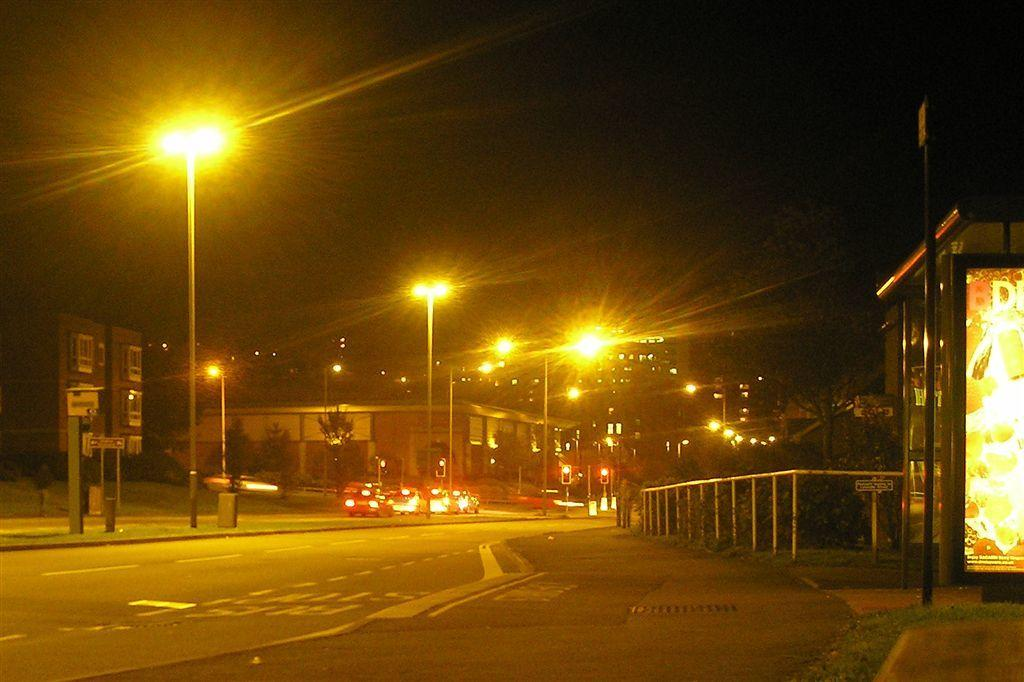What type of vehicles can be seen on the road in the image? There are motor vehicles on the road in the image. What structures are present along the road? Street poles and street lights are visible in the image. What type of barrier is present in the image? There is a fence in the image. What type of vegetation is present in the image? Trees are present in the image. What part of the natural environment is visible in the image? The sky is visible in the image. Can you see a boy walking through the fog in the image? There is no boy or fog present in the image. How do the street lights join together to form a pattern in the image? The street lights are not shown joining together to form a pattern in the image; they are separate and distinct. 